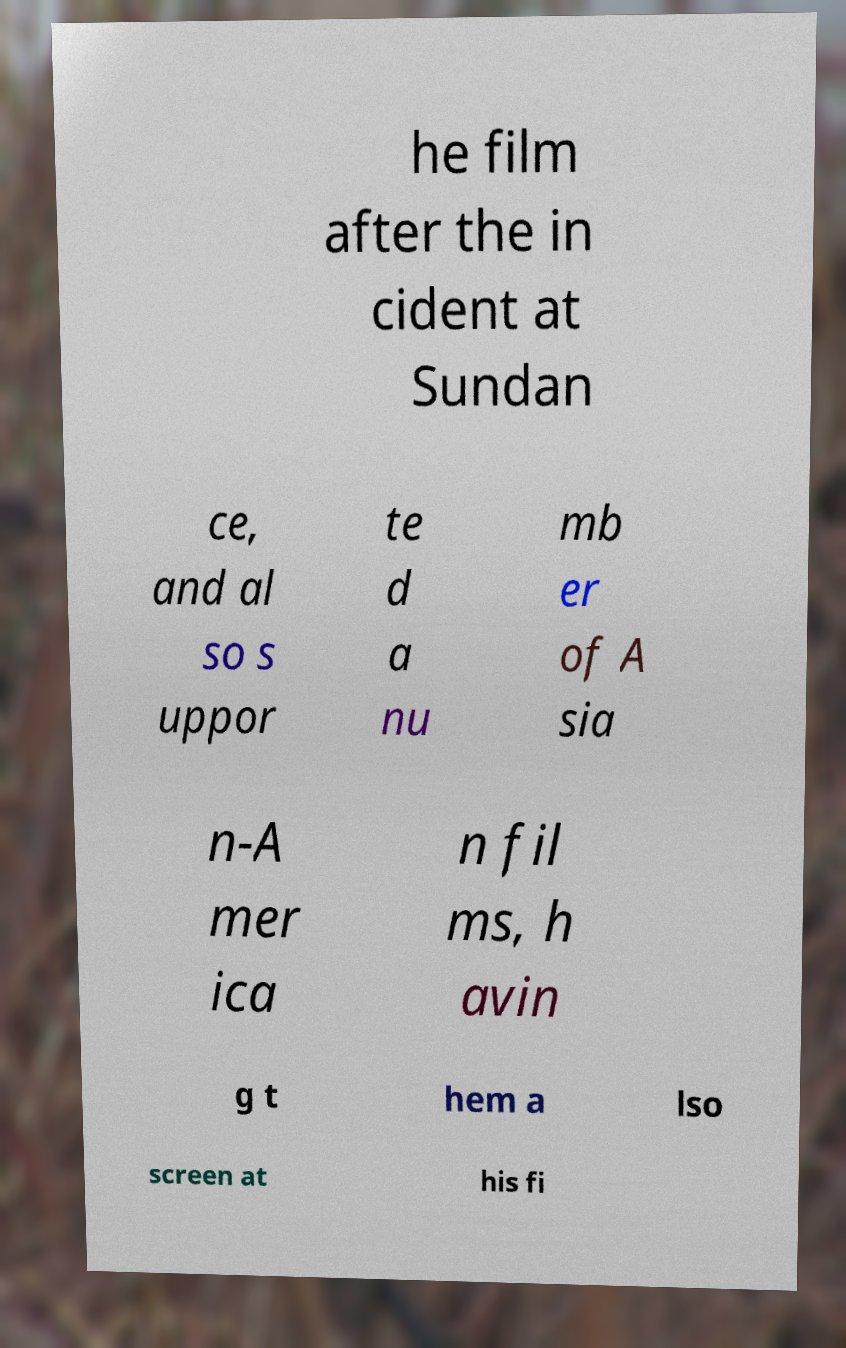Could you extract and type out the text from this image? he film after the in cident at Sundan ce, and al so s uppor te d a nu mb er of A sia n-A mer ica n fil ms, h avin g t hem a lso screen at his fi 